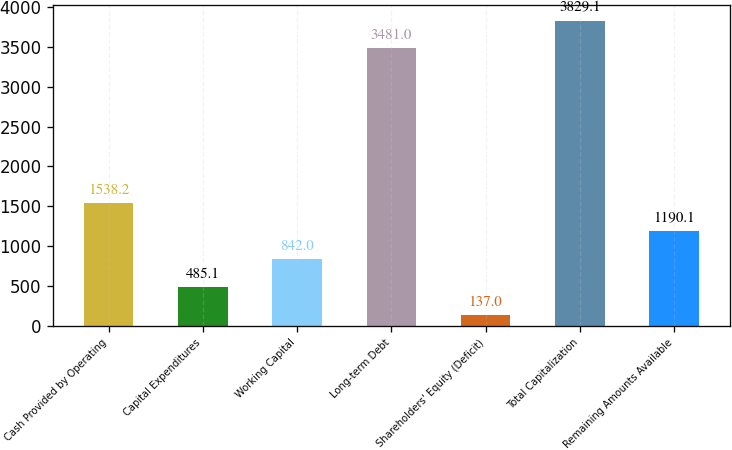<chart> <loc_0><loc_0><loc_500><loc_500><bar_chart><fcel>Cash Provided by Operating<fcel>Capital Expenditures<fcel>Working Capital<fcel>Long-term Debt<fcel>Shareholders' Equity (Deficit)<fcel>Total Capitalization<fcel>Remaining Amounts Available<nl><fcel>1538.2<fcel>485.1<fcel>842<fcel>3481<fcel>137<fcel>3829.1<fcel>1190.1<nl></chart> 